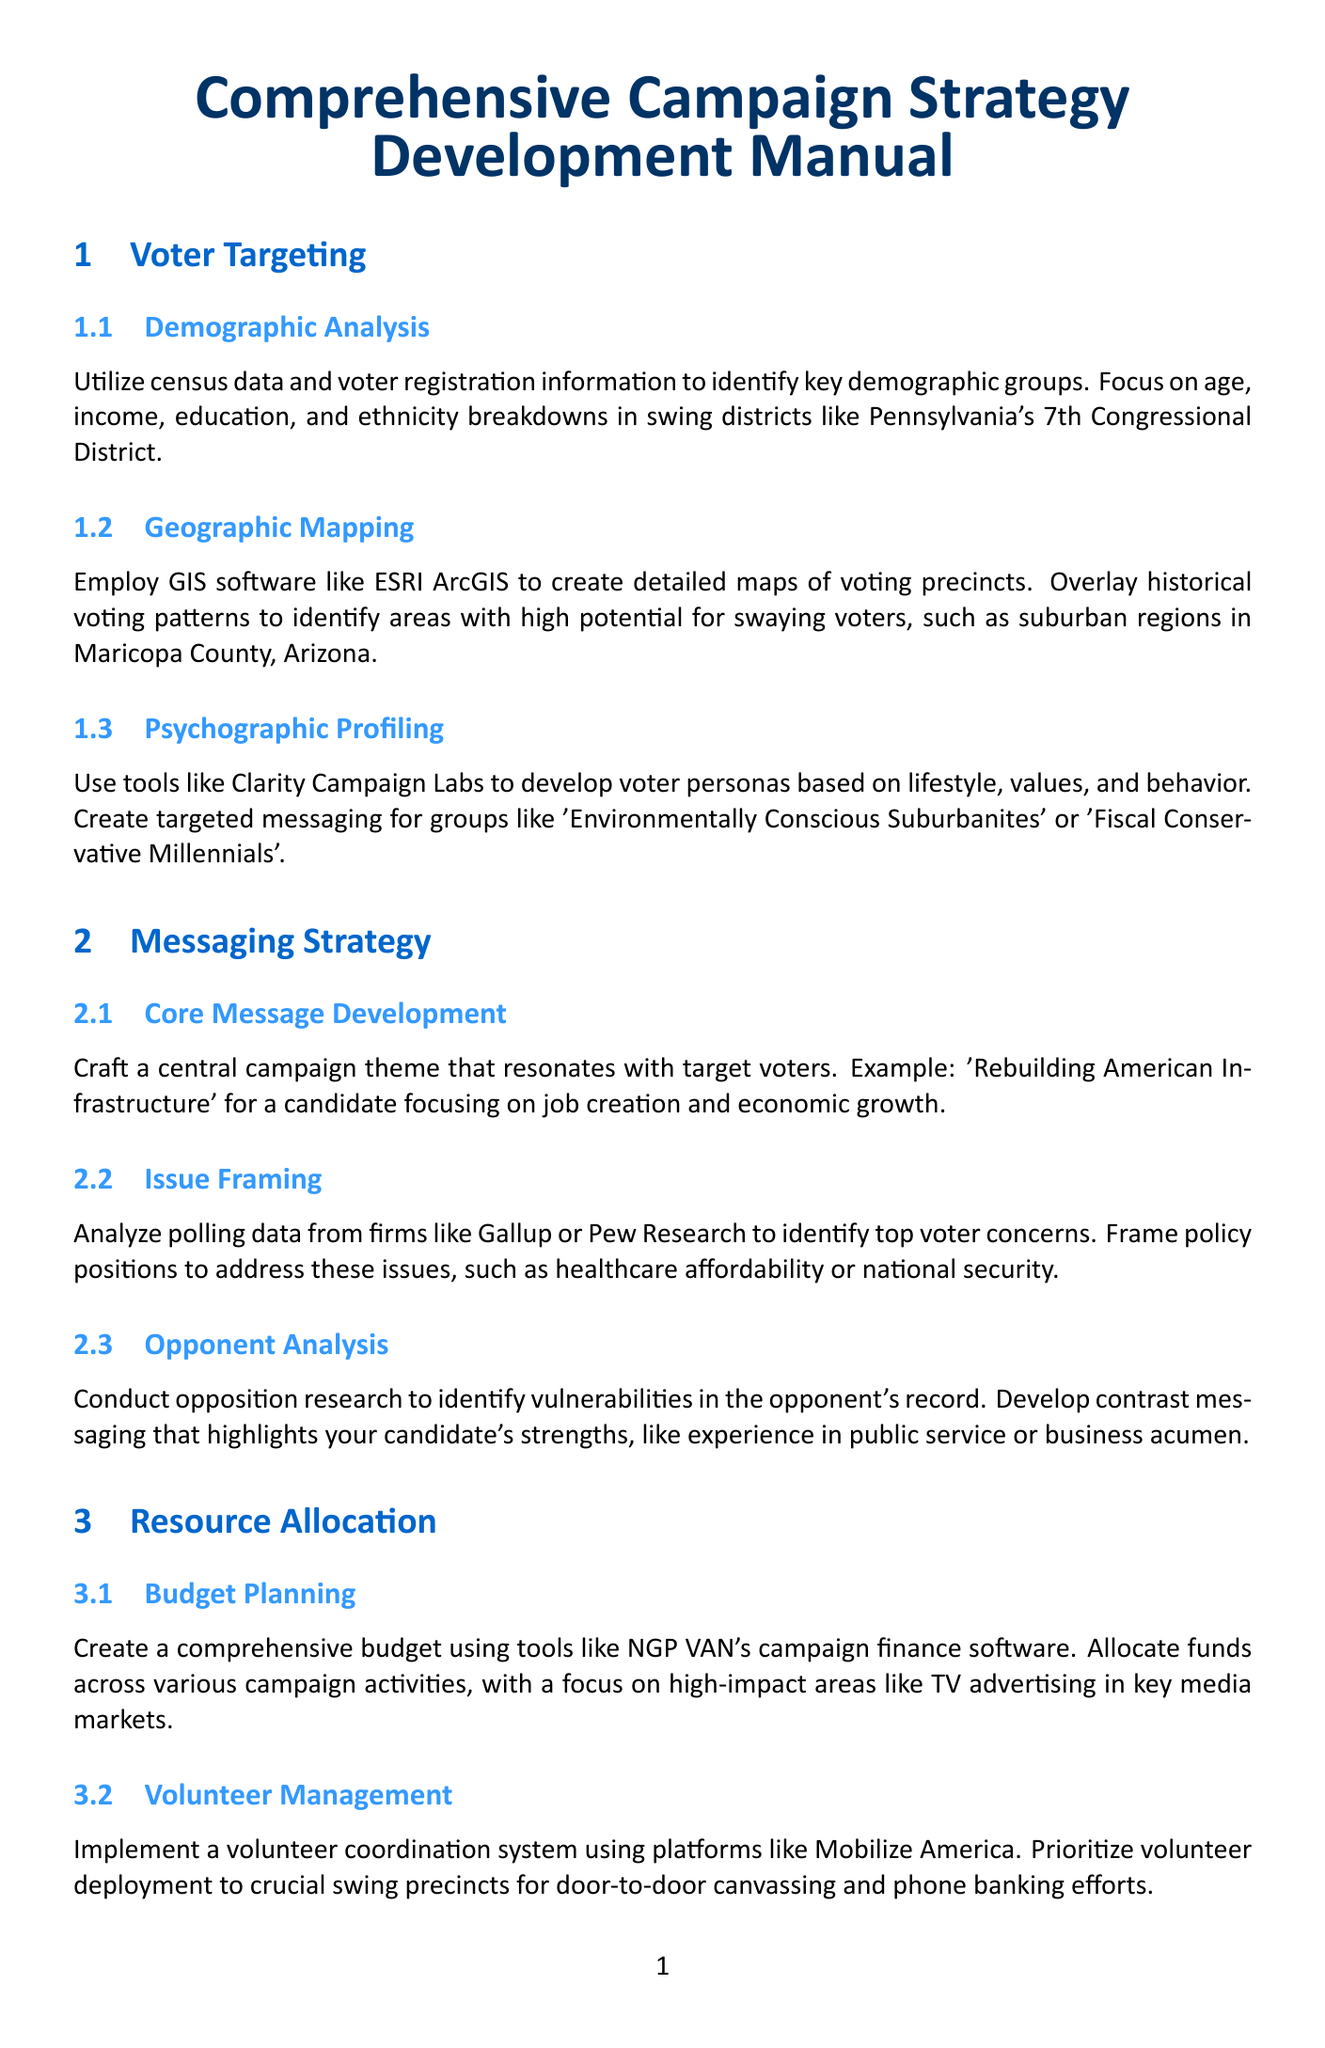What is the title of the manual? The title of the manual is clearly stated at the beginning of the document.
Answer: Comprehensive Campaign Strategy Development Manual Which software is recommended for Geographic Mapping? The document mentions a specific software used for creating maps in the context of voter targeting.
Answer: ESRI ArcGIS What is the focus of the Core Message Development subsection? This subsection provides an example of a campaign theme that resonates with voters.
Answer: Rebuilding American Infrastructure What is the purpose of A/B Testing according to the document? The document explains the main goal of implementing A/B testing for campaign materials.
Answer: Maximize engagement and conversion rates Which interest group is mentioned for Outreach in the Coalition Building section? An example of an interest group relevant to climate-focused campaigns is provided in the document.
Answer: Sierra Club How many subsections are there under Resource Allocation? The document provides a list of subsections within this particular section.
Answer: Three What is the priority for Volunteer Management? This part of the document discusses where volunteers should be deployed for maximum impact.
Answer: Crucial swing precincts What are the tools suggested for Polling and Analytics? The document lists specific firms used for conducting regular polling in this strategy.
Answer: Quinnipiac University Polling Institute or Monmouth University Polling Institute 